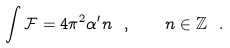<formula> <loc_0><loc_0><loc_500><loc_500>\int \mathcal { F } = 4 \pi ^ { 2 } \alpha ^ { \prime } n \ , \quad n \in \mathbb { Z } \ .</formula> 